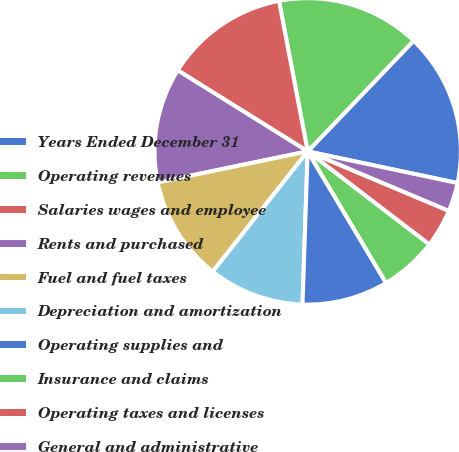Convert chart. <chart><loc_0><loc_0><loc_500><loc_500><pie_chart><fcel>Years Ended December 31<fcel>Operating revenues<fcel>Salaries wages and employee<fcel>Rents and purchased<fcel>Fuel and fuel taxes<fcel>Depreciation and amortization<fcel>Operating supplies and<fcel>Insurance and claims<fcel>Operating taxes and licenses<fcel>General and administrative<nl><fcel>16.16%<fcel>15.15%<fcel>13.13%<fcel>12.12%<fcel>11.11%<fcel>10.1%<fcel>9.09%<fcel>6.06%<fcel>4.04%<fcel>3.03%<nl></chart> 